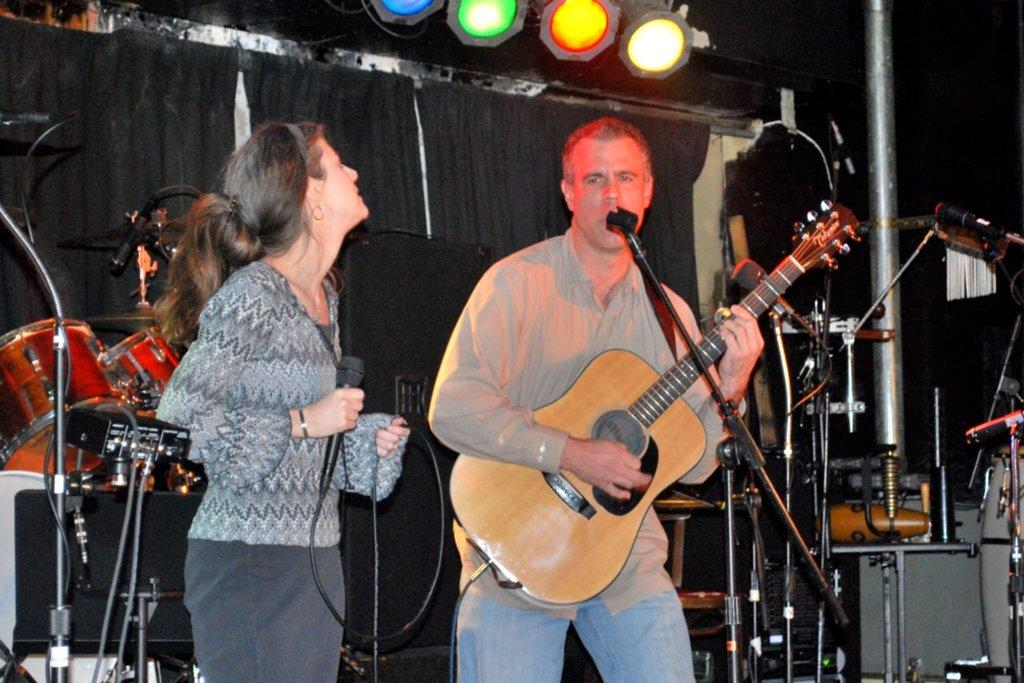How many people are present in the image? There are two people in the image, a man and a woman. What is the man holding in the image? The man is holding a guitar. What is the woman holding in the image? The woman is holding a microphone. What can be seen in the background of the image? There is a drum set, additional microphones, and lights in the background of the image. What type of pest can be seen crawling on the boundary in the image? There is no pest or boundary present in the image; it features a man holding a guitar, a woman holding a microphone, and various musical equipment in the background. 